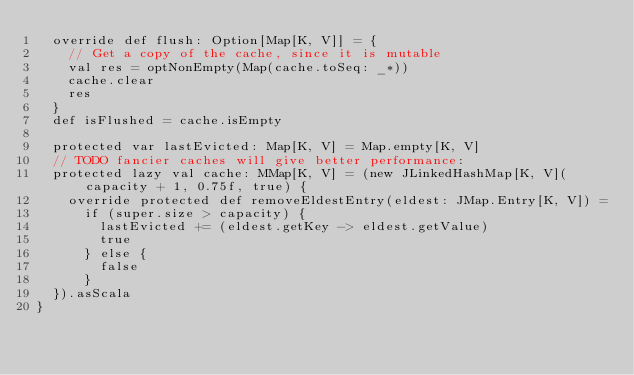Convert code to text. <code><loc_0><loc_0><loc_500><loc_500><_Scala_>  override def flush: Option[Map[K, V]] = {
    // Get a copy of the cache, since it is mutable
    val res = optNonEmpty(Map(cache.toSeq: _*))
    cache.clear
    res
  }
  def isFlushed = cache.isEmpty

  protected var lastEvicted: Map[K, V] = Map.empty[K, V]
  // TODO fancier caches will give better performance:
  protected lazy val cache: MMap[K, V] = (new JLinkedHashMap[K, V](capacity + 1, 0.75f, true) {
    override protected def removeEldestEntry(eldest: JMap.Entry[K, V]) =
      if (super.size > capacity) {
        lastEvicted += (eldest.getKey -> eldest.getValue)
        true
      } else {
        false
      }
  }).asScala
}
</code> 